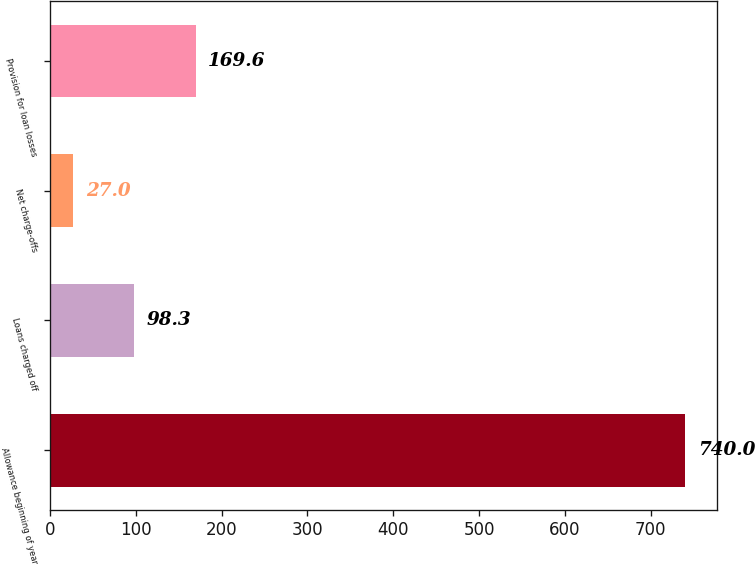Convert chart to OTSL. <chart><loc_0><loc_0><loc_500><loc_500><bar_chart><fcel>Allowance beginning of year<fcel>Loans charged off<fcel>Net charge-offs<fcel>Provision for loan losses<nl><fcel>740<fcel>98.3<fcel>27<fcel>169.6<nl></chart> 